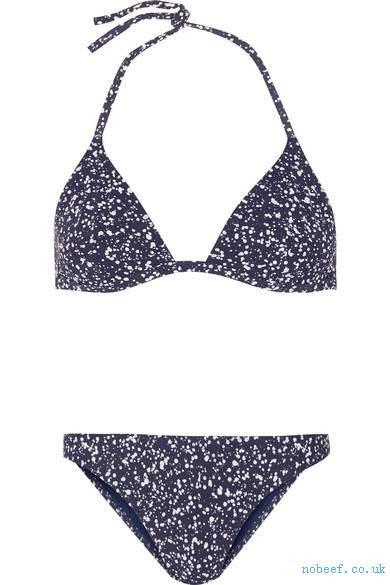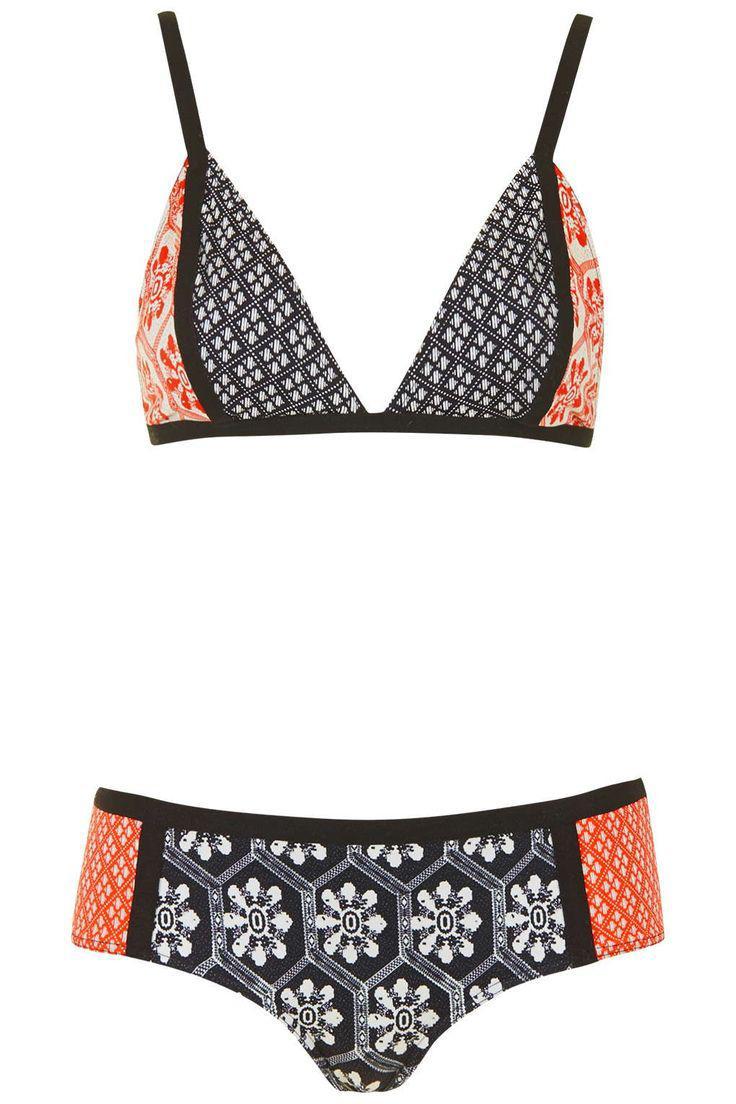The first image is the image on the left, the second image is the image on the right. Analyze the images presented: Is the assertion "One of the swimsuits has a floral pattern" valid? Answer yes or no. Yes. 